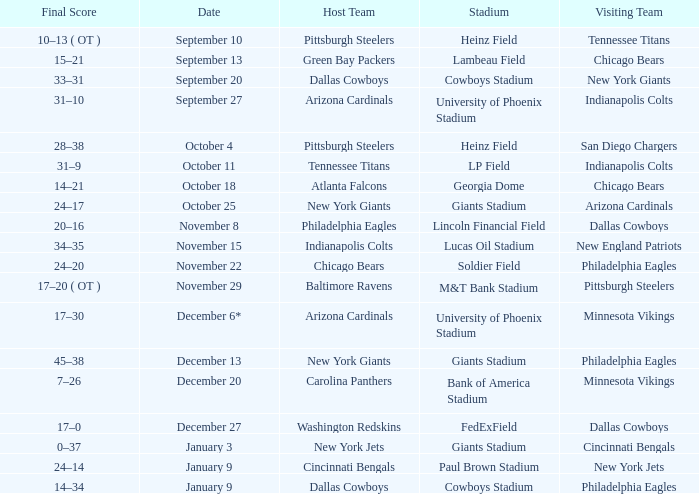Tell me the date for pittsburgh steelers November 29. 